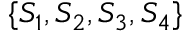Convert formula to latex. <formula><loc_0><loc_0><loc_500><loc_500>\{ S _ { 1 } , S _ { 2 } , S _ { 3 } , S _ { 4 } \}</formula> 